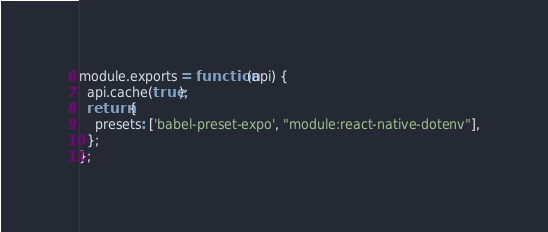<code> <loc_0><loc_0><loc_500><loc_500><_JavaScript_>module.exports = function(api) {
  api.cache(true);
  return {
    presets: ['babel-preset-expo', "module:react-native-dotenv"],
  };
};
</code> 